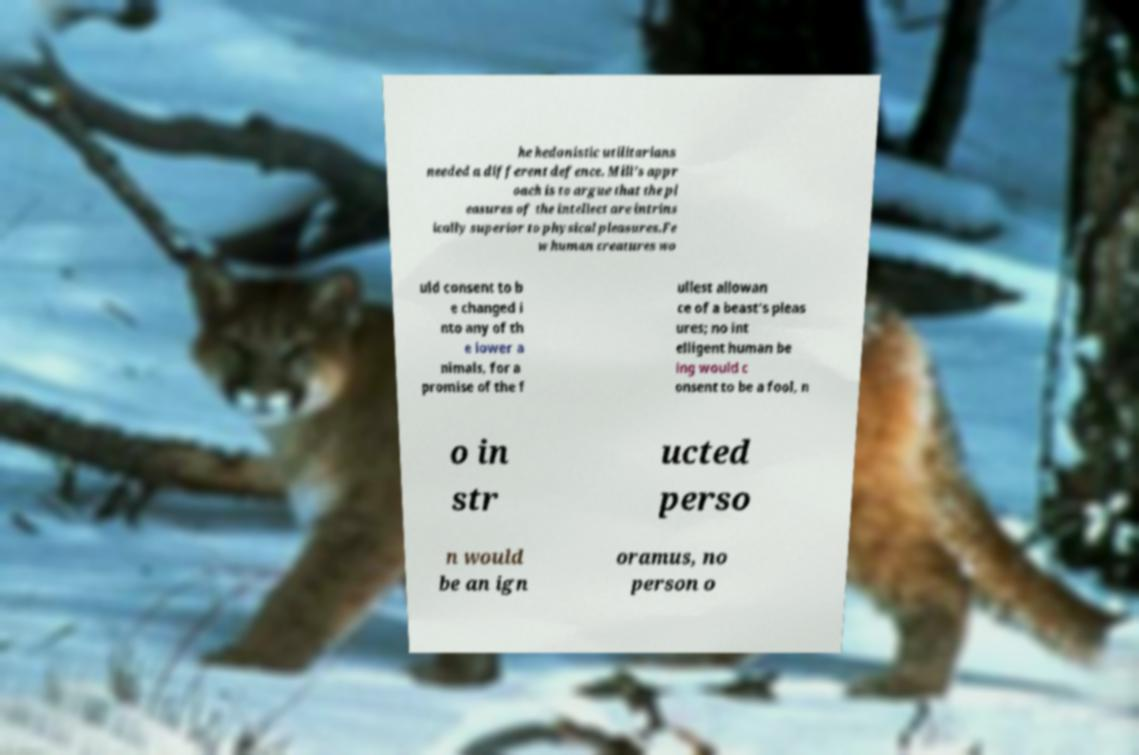Can you accurately transcribe the text from the provided image for me? he hedonistic utilitarians needed a different defence. Mill's appr oach is to argue that the pl easures of the intellect are intrins ically superior to physical pleasures.Fe w human creatures wo uld consent to b e changed i nto any of th e lower a nimals, for a promise of the f ullest allowan ce of a beast's pleas ures; no int elligent human be ing would c onsent to be a fool, n o in str ucted perso n would be an ign oramus, no person o 